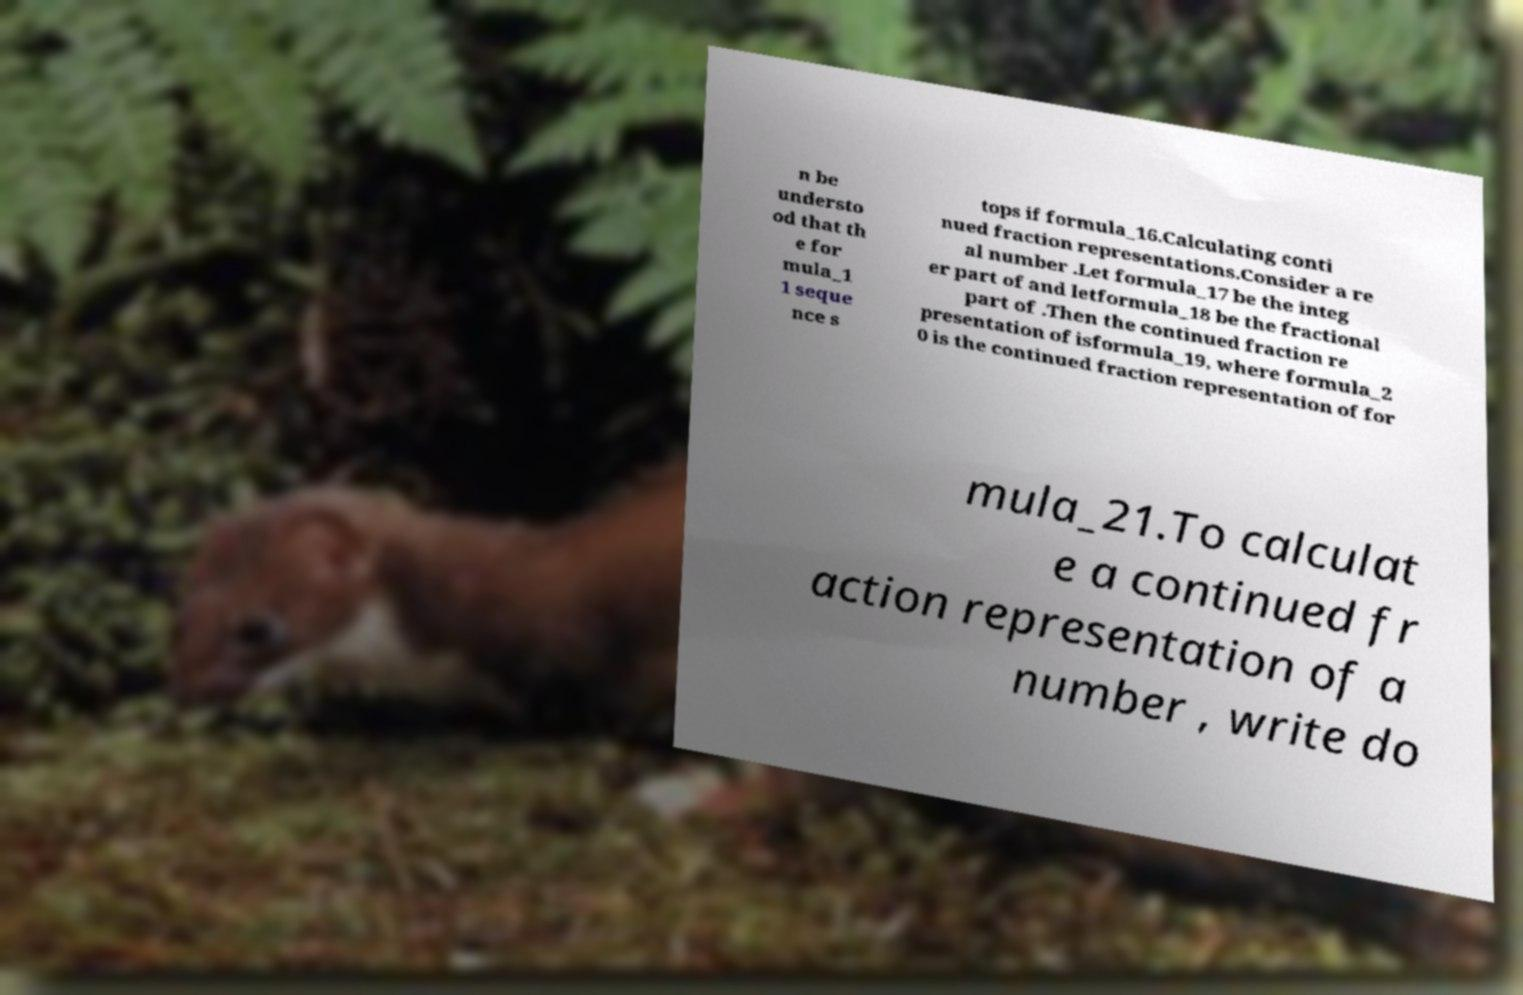Please read and relay the text visible in this image. What does it say? n be understo od that th e for mula_1 1 seque nce s tops if formula_16.Calculating conti nued fraction representations.Consider a re al number .Let formula_17 be the integ er part of and letformula_18 be the fractional part of .Then the continued fraction re presentation of isformula_19, where formula_2 0 is the continued fraction representation of for mula_21.To calculat e a continued fr action representation of a number , write do 